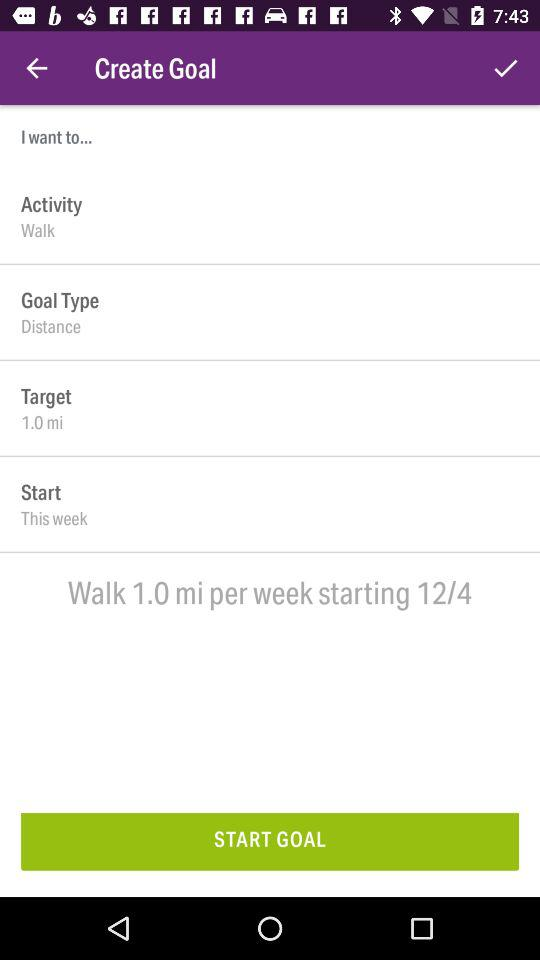How many miles per week do we need to walk? You need to walk 1 mile per week. 